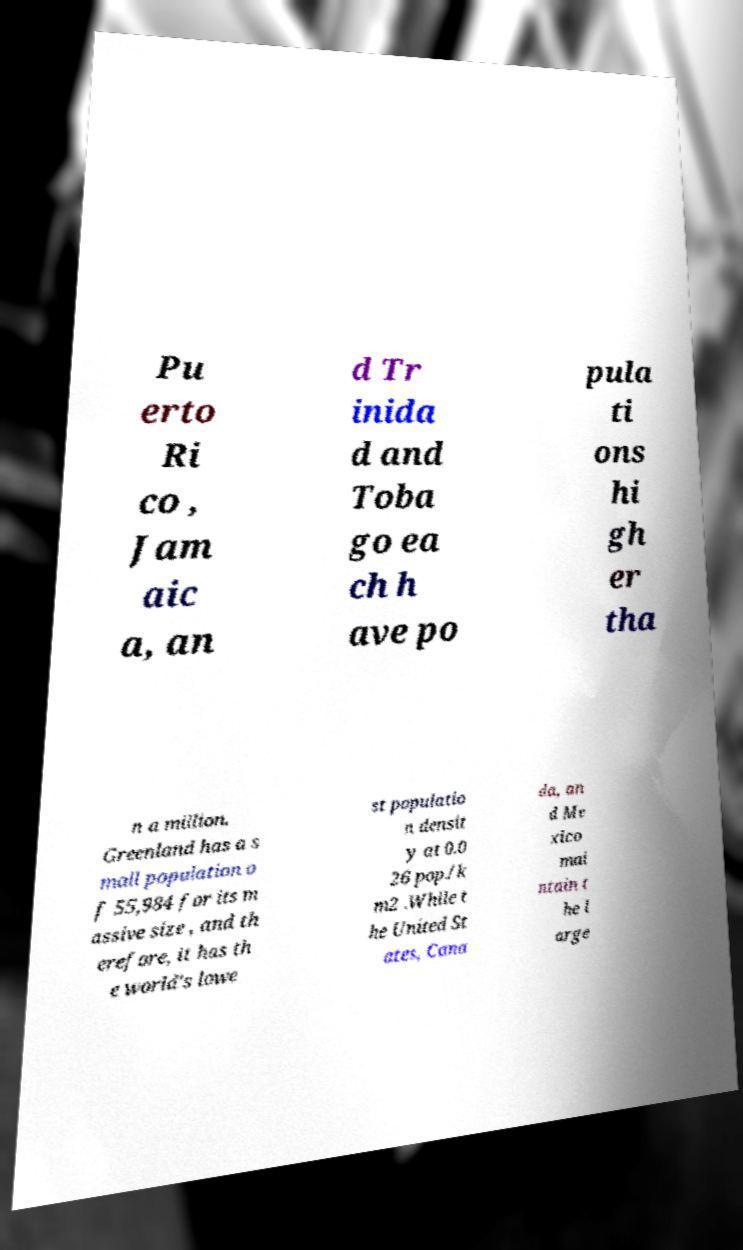There's text embedded in this image that I need extracted. Can you transcribe it verbatim? Pu erto Ri co , Jam aic a, an d Tr inida d and Toba go ea ch h ave po pula ti ons hi gh er tha n a million. Greenland has a s mall population o f 55,984 for its m assive size , and th erefore, it has th e world's lowe st populatio n densit y at 0.0 26 pop./k m2 .While t he United St ates, Cana da, an d Me xico mai ntain t he l arge 